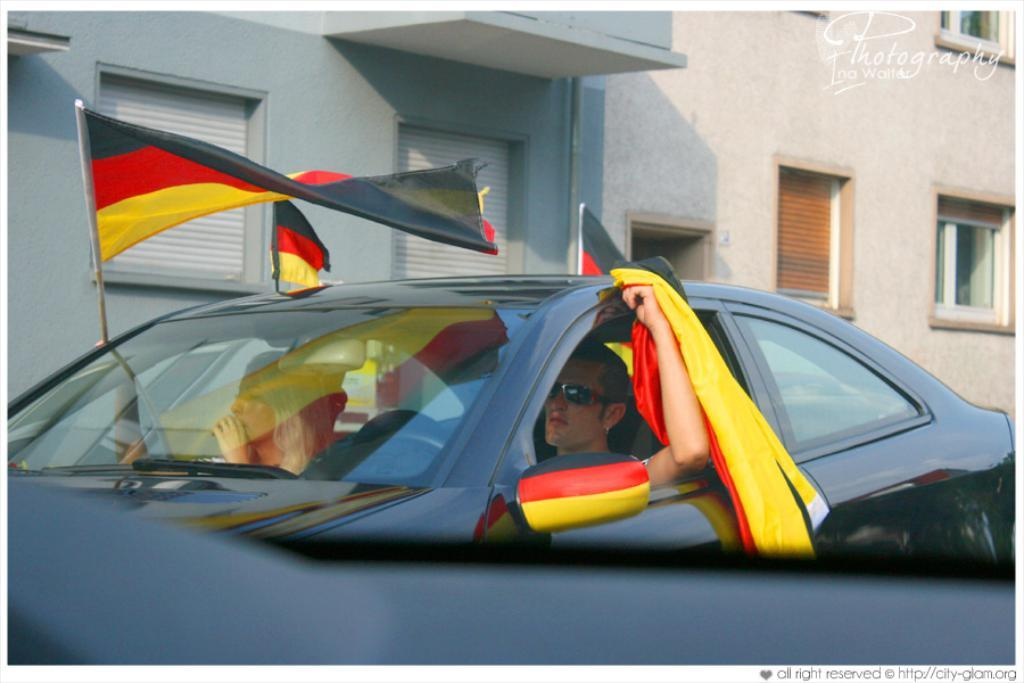Who is present in the image? There is a man and a woman in the image. What are they doing in the image? Both the man and woman are sitting inside a car. What are they holding in the image? They are holding flags. What can be seen in the background of the image? There is a building with windows visible in the image. What type of street can be seen in the image? There is no street visible in the image; it features a man and a woman sitting inside a car with flags and a building with windows in the background. 